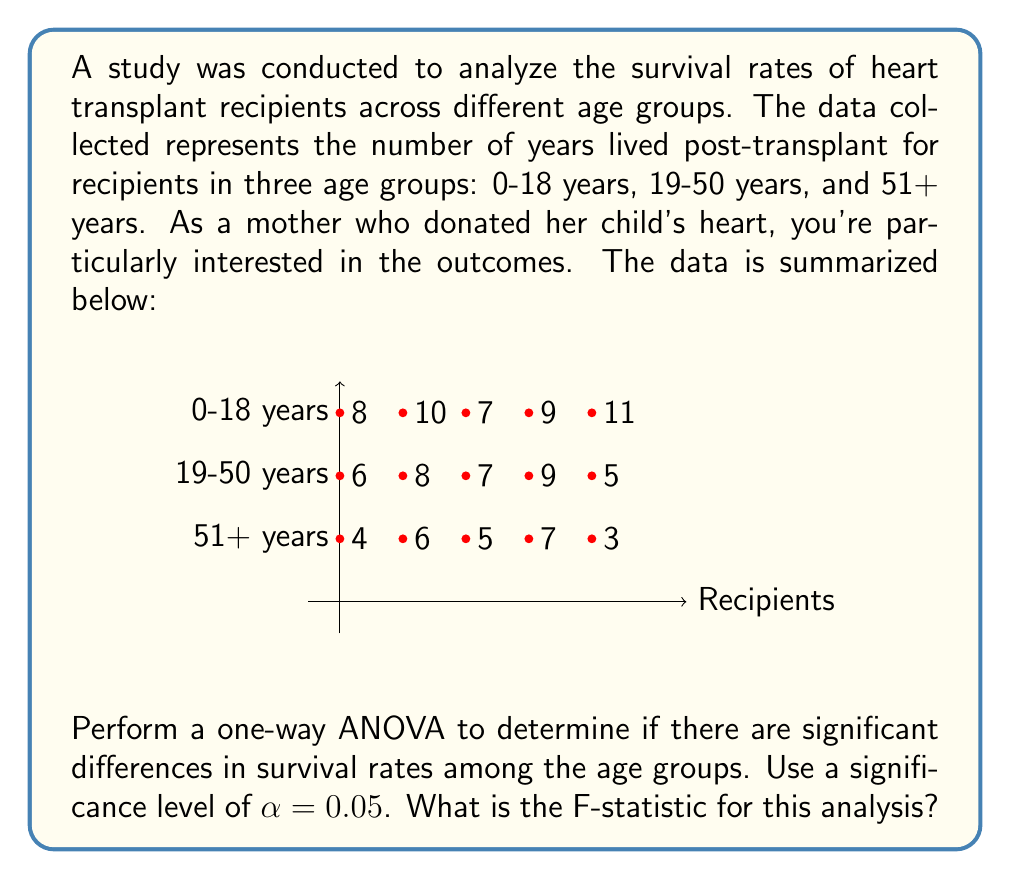Teach me how to tackle this problem. To perform a one-way ANOVA, we need to follow these steps:

1) Calculate the mean for each group and the overall mean:
   0-18 years: $\bar{X}_1 = (8+10+7+9+11)/5 = 9$
   19-50 years: $\bar{X}_2 = (6+8+7+9+5)/5 = 7$
   51+ years: $\bar{X}_3 = (4+6+5+7+3)/5 = 5$
   Overall mean: $\bar{X} = (9+7+5)/3 = 7$

2) Calculate the Sum of Squares Between (SSB):
   $$SSB = \sum_{i=1}^k n_i(\bar{X}_i - \bar{X})^2$$
   where $k$ is the number of groups and $n_i$ is the number of observations in each group.
   $$SSB = 5(9-7)^2 + 5(7-7)^2 + 5(5-7)^2 = 40$$

3) Calculate the Sum of Squares Within (SSW):
   $$SSW = \sum_{i=1}^k \sum_{j=1}^{n_i} (X_{ij} - \bar{X}_i)^2$$
   $$SSW = [(8-9)^2 + (10-9)^2 + (7-9)^2 + (9-9)^2 + (11-9)^2] + \\
           [(6-7)^2 + (8-7)^2 + (7-7)^2 + (9-7)^2 + (5-7)^2] + \\
           [(4-5)^2 + (6-5)^2 + (5-5)^2 + (7-5)^2 + (3-5)^2]$$
   $$SSW = 14 + 14 + 14 = 42$$

4) Calculate the degrees of freedom:
   Between groups: $df_B = k - 1 = 3 - 1 = 2$
   Within groups: $df_W = N - k = 15 - 3 = 12$
   where $N$ is the total number of observations.

5) Calculate the Mean Square Between (MSB) and Mean Square Within (MSW):
   $$MSB = SSB / df_B = 40 / 2 = 20$$
   $$MSW = SSW / df_W = 42 / 12 = 3.5$$

6) Calculate the F-statistic:
   $$F = MSB / MSW = 20 / 3.5 = 5.71$$

Therefore, the F-statistic for this analysis is 5.71.
Answer: $F = 5.71$ 